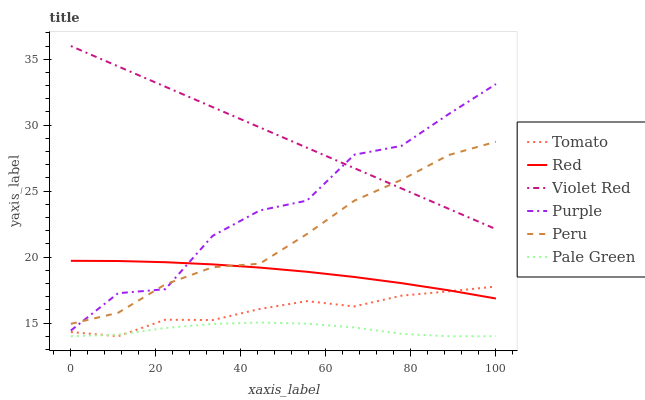Does Pale Green have the minimum area under the curve?
Answer yes or no. Yes. Does Violet Red have the maximum area under the curve?
Answer yes or no. Yes. Does Purple have the minimum area under the curve?
Answer yes or no. No. Does Purple have the maximum area under the curve?
Answer yes or no. No. Is Violet Red the smoothest?
Answer yes or no. Yes. Is Purple the roughest?
Answer yes or no. Yes. Is Purple the smoothest?
Answer yes or no. No. Is Violet Red the roughest?
Answer yes or no. No. Does Tomato have the lowest value?
Answer yes or no. Yes. Does Purple have the lowest value?
Answer yes or no. No. Does Violet Red have the highest value?
Answer yes or no. Yes. Does Purple have the highest value?
Answer yes or no. No. Is Pale Green less than Violet Red?
Answer yes or no. Yes. Is Peru greater than Tomato?
Answer yes or no. Yes. Does Purple intersect Violet Red?
Answer yes or no. Yes. Is Purple less than Violet Red?
Answer yes or no. No. Is Purple greater than Violet Red?
Answer yes or no. No. Does Pale Green intersect Violet Red?
Answer yes or no. No. 